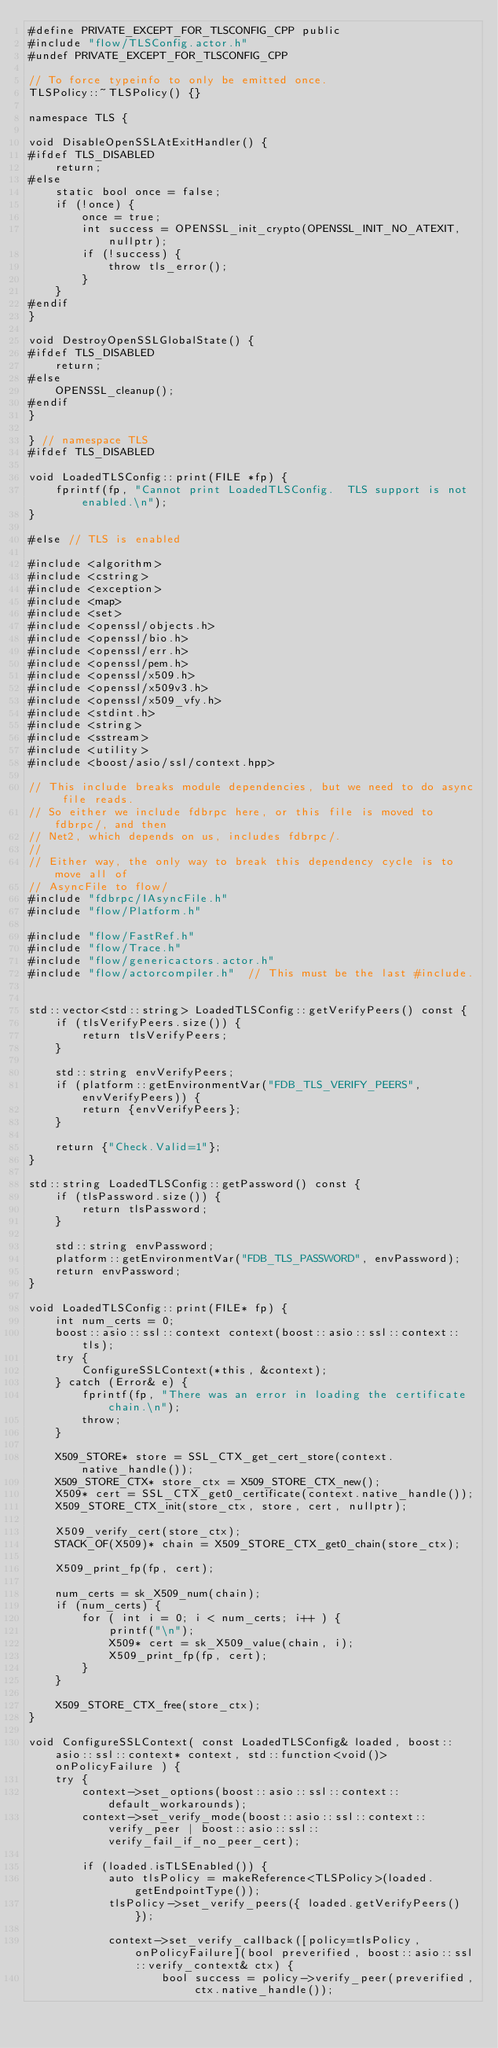Convert code to text. <code><loc_0><loc_0><loc_500><loc_500><_C++_>#define PRIVATE_EXCEPT_FOR_TLSCONFIG_CPP public
#include "flow/TLSConfig.actor.h"
#undef PRIVATE_EXCEPT_FOR_TLSCONFIG_CPP

// To force typeinfo to only be emitted once.
TLSPolicy::~TLSPolicy() {}

namespace TLS {

void DisableOpenSSLAtExitHandler() {
#ifdef TLS_DISABLED
	return;
#else
	static bool once = false;
	if (!once) {
		once = true;
		int success = OPENSSL_init_crypto(OPENSSL_INIT_NO_ATEXIT, nullptr);
		if (!success) {
			throw tls_error();
		}
	}
#endif
}

void DestroyOpenSSLGlobalState() {
#ifdef TLS_DISABLED
	return;
#else
	OPENSSL_cleanup();
#endif
}

} // namespace TLS
#ifdef TLS_DISABLED

void LoadedTLSConfig::print(FILE *fp) {
	fprintf(fp, "Cannot print LoadedTLSConfig.  TLS support is not enabled.\n");
}

#else // TLS is enabled

#include <algorithm>
#include <cstring>
#include <exception>
#include <map>
#include <set>
#include <openssl/objects.h>
#include <openssl/bio.h>
#include <openssl/err.h>
#include <openssl/pem.h>
#include <openssl/x509.h>
#include <openssl/x509v3.h>
#include <openssl/x509_vfy.h>
#include <stdint.h>
#include <string>
#include <sstream>
#include <utility>
#include <boost/asio/ssl/context.hpp>

// This include breaks module dependencies, but we need to do async file reads.
// So either we include fdbrpc here, or this file is moved to fdbrpc/, and then
// Net2, which depends on us, includes fdbrpc/.
//
// Either way, the only way to break this dependency cycle is to move all of
// AsyncFile to flow/
#include "fdbrpc/IAsyncFile.h"
#include "flow/Platform.h"

#include "flow/FastRef.h"
#include "flow/Trace.h"
#include "flow/genericactors.actor.h"
#include "flow/actorcompiler.h"  // This must be the last #include.


std::vector<std::string> LoadedTLSConfig::getVerifyPeers() const {
	if (tlsVerifyPeers.size()) {
		return tlsVerifyPeers;
	}

	std::string envVerifyPeers;
	if (platform::getEnvironmentVar("FDB_TLS_VERIFY_PEERS", envVerifyPeers)) {
		return {envVerifyPeers};
	}

	return {"Check.Valid=1"};
}

std::string LoadedTLSConfig::getPassword() const {
	if (tlsPassword.size()) {
		return tlsPassword;
	}

	std::string envPassword;
	platform::getEnvironmentVar("FDB_TLS_PASSWORD", envPassword);
	return envPassword;
}

void LoadedTLSConfig::print(FILE* fp) {
	int num_certs = 0;
	boost::asio::ssl::context context(boost::asio::ssl::context::tls);
	try {
		ConfigureSSLContext(*this, &context);
	} catch (Error& e) {
		fprintf(fp, "There was an error in loading the certificate chain.\n");
		throw;
	}

	X509_STORE* store = SSL_CTX_get_cert_store(context.native_handle());
	X509_STORE_CTX* store_ctx = X509_STORE_CTX_new();
	X509* cert = SSL_CTX_get0_certificate(context.native_handle());
	X509_STORE_CTX_init(store_ctx, store, cert, nullptr);

	X509_verify_cert(store_ctx);
	STACK_OF(X509)* chain = X509_STORE_CTX_get0_chain(store_ctx);

	X509_print_fp(fp, cert);

	num_certs = sk_X509_num(chain);
	if (num_certs) {
		for ( int i = 0; i < num_certs; i++ ) {
			printf("\n");
			X509* cert = sk_X509_value(chain, i);
			X509_print_fp(fp, cert);
		}
	}

	X509_STORE_CTX_free(store_ctx);
}

void ConfigureSSLContext( const LoadedTLSConfig& loaded, boost::asio::ssl::context* context, std::function<void()> onPolicyFailure ) {
	try {
		context->set_options(boost::asio::ssl::context::default_workarounds);
		context->set_verify_mode(boost::asio::ssl::context::verify_peer | boost::asio::ssl::verify_fail_if_no_peer_cert);

		if (loaded.isTLSEnabled()) {
			auto tlsPolicy = makeReference<TLSPolicy>(loaded.getEndpointType());
			tlsPolicy->set_verify_peers({ loaded.getVerifyPeers() });

			context->set_verify_callback([policy=tlsPolicy, onPolicyFailure](bool preverified, boost::asio::ssl::verify_context& ctx) {
					bool success = policy->verify_peer(preverified, ctx.native_handle());</code> 